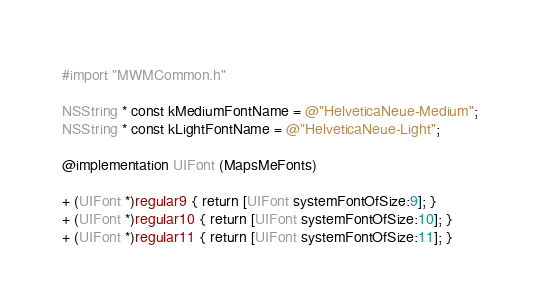Convert code to text. <code><loc_0><loc_0><loc_500><loc_500><_ObjectiveC_>#import "MWMCommon.h"

NSString * const kMediumFontName = @"HelveticaNeue-Medium";
NSString * const kLightFontName = @"HelveticaNeue-Light";

@implementation UIFont (MapsMeFonts)

+ (UIFont *)regular9 { return [UIFont systemFontOfSize:9]; }
+ (UIFont *)regular10 { return [UIFont systemFontOfSize:10]; }
+ (UIFont *)regular11 { return [UIFont systemFontOfSize:11]; }</code> 